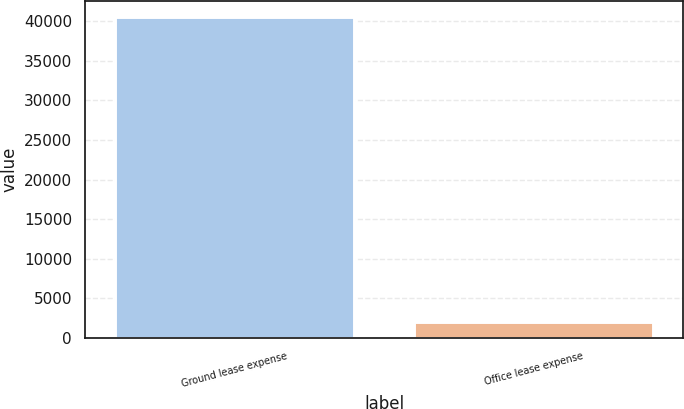Convert chart. <chart><loc_0><loc_0><loc_500><loc_500><bar_chart><fcel>Ground lease expense<fcel>Office lease expense<nl><fcel>40518<fcel>2004<nl></chart> 